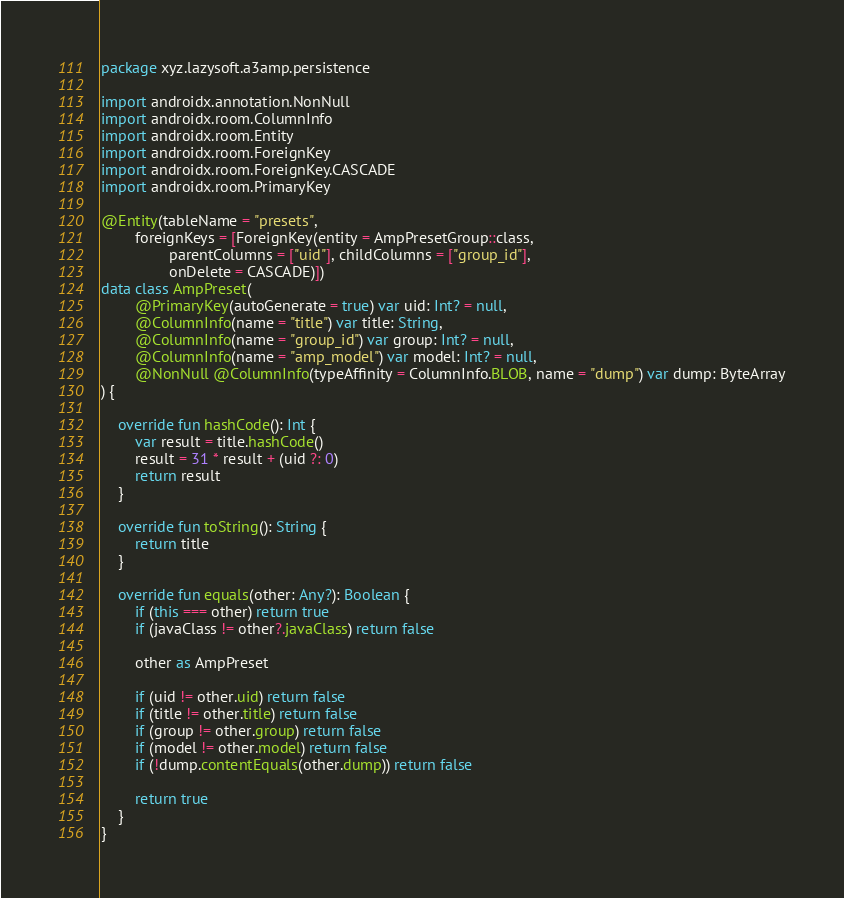Convert code to text. <code><loc_0><loc_0><loc_500><loc_500><_Kotlin_>package xyz.lazysoft.a3amp.persistence

import androidx.annotation.NonNull
import androidx.room.ColumnInfo
import androidx.room.Entity
import androidx.room.ForeignKey
import androidx.room.ForeignKey.CASCADE
import androidx.room.PrimaryKey

@Entity(tableName = "presets",
        foreignKeys = [ForeignKey(entity = AmpPresetGroup::class,
                parentColumns = ["uid"], childColumns = ["group_id"],
                onDelete = CASCADE)])
data class AmpPreset(
        @PrimaryKey(autoGenerate = true) var uid: Int? = null,
        @ColumnInfo(name = "title") var title: String,
        @ColumnInfo(name = "group_id") var group: Int? = null,
        @ColumnInfo(name = "amp_model") var model: Int? = null,
        @NonNull @ColumnInfo(typeAffinity = ColumnInfo.BLOB, name = "dump") var dump: ByteArray
) {

    override fun hashCode(): Int {
        var result = title.hashCode()
        result = 31 * result + (uid ?: 0)
        return result
    }

    override fun toString(): String {
        return title
    }

    override fun equals(other: Any?): Boolean {
        if (this === other) return true
        if (javaClass != other?.javaClass) return false

        other as AmpPreset

        if (uid != other.uid) return false
        if (title != other.title) return false
        if (group != other.group) return false
        if (model != other.model) return false
        if (!dump.contentEquals(other.dump)) return false

        return true
    }
}</code> 